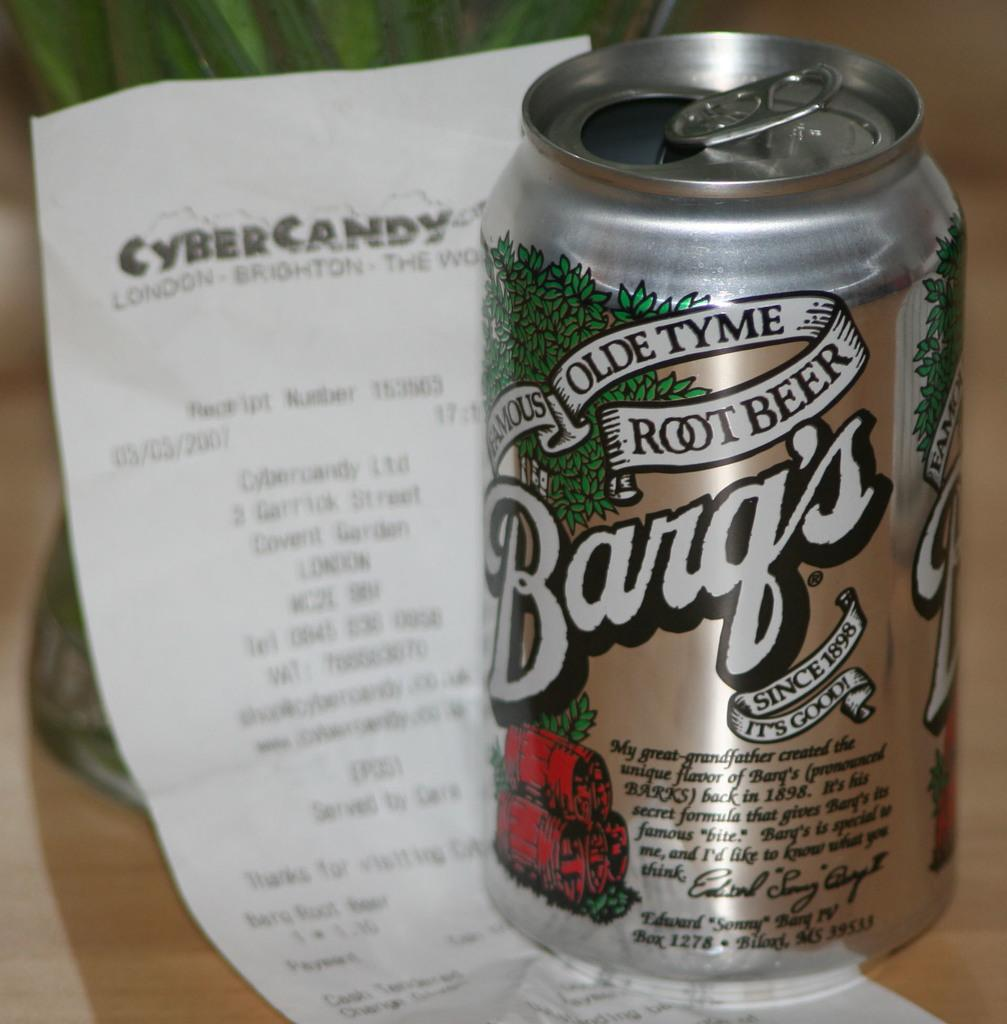<image>
Offer a succinct explanation of the picture presented. A silver can of Barq's Root Beer is in focus on a hard wooden surface and a receipt of some kind is in the background 